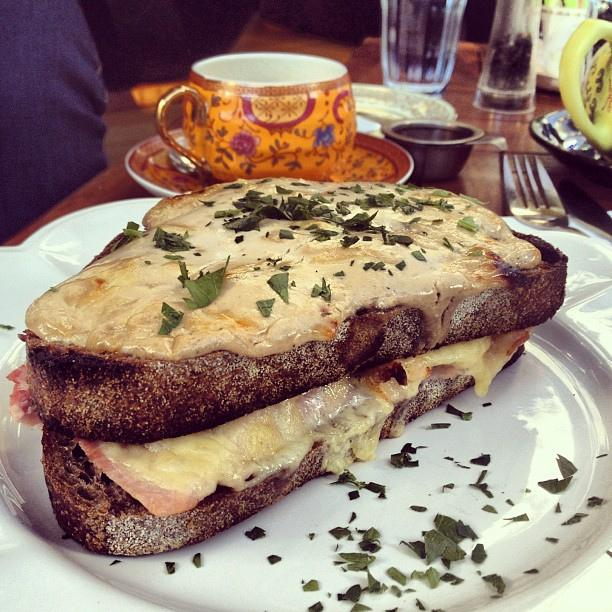What is in the sandwich? cheese 